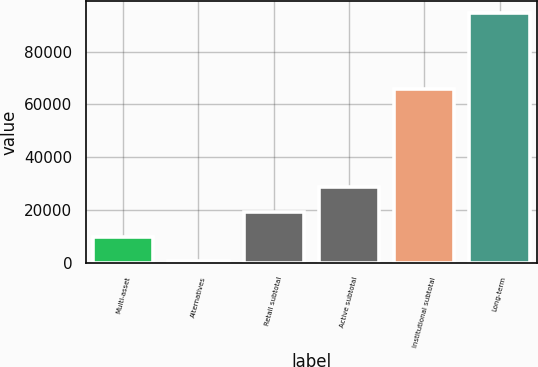Convert chart to OTSL. <chart><loc_0><loc_0><loc_500><loc_500><bar_chart><fcel>Multi-asset<fcel>Alternatives<fcel>Retail subtotal<fcel>Active subtotal<fcel>Institutional subtotal<fcel>Long-term<nl><fcel>9985.5<fcel>591<fcel>19380<fcel>28774.5<fcel>65765<fcel>94536<nl></chart> 